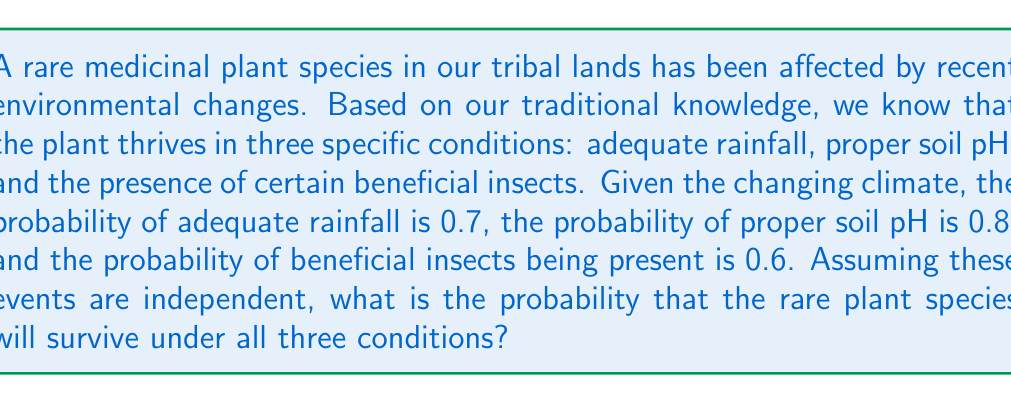Solve this math problem. Let's approach this step-by-step:

1) We need to find the probability of all three conditions occurring simultaneously.

2) Given:
   P(adequate rainfall) = 0.7
   P(proper soil pH) = 0.8
   P(beneficial insects present) = 0.6

3) Since the events are independent, we can use the multiplication rule of probability. The probability of all independent events occurring together is the product of their individual probabilities.

4) Let's define the event S as the survival of the plant species under all three conditions:

   $$P(S) = P(\text{rainfall}) \times P(\text{soil pH}) \times P(\text{insects})$$

5) Substituting the given probabilities:

   $$P(S) = 0.7 \times 0.8 \times 0.6$$

6) Calculating:

   $$P(S) = 0.336$$

7) Therefore, the probability that the rare plant species will survive under all three conditions is 0.336 or 33.6%.
Answer: 0.336 